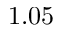<formula> <loc_0><loc_0><loc_500><loc_500>1 . 0 5</formula> 